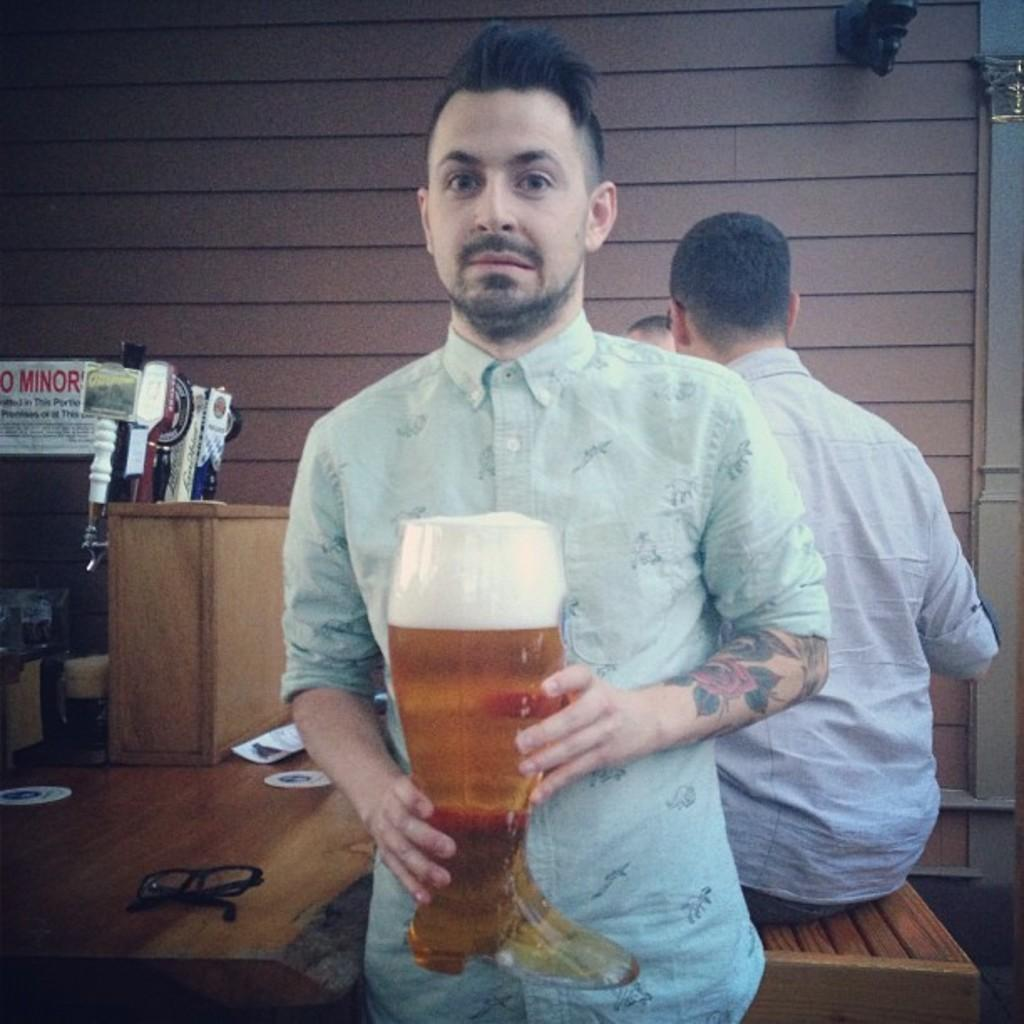How many people are in the image? There are three persons in the image. What is the man holding in the image? The man is holding a glass. Where are the glasses located in the image? There are glasses on a table in the image. What else can be found on the table in the image? There are objects on the table in the image. What is the weight of the paste on the table in the image? There is no paste present on the table in the image. 